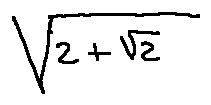Convert formula to latex. <formula><loc_0><loc_0><loc_500><loc_500>\sqrt { 2 + \sqrt { 2 } }</formula> 